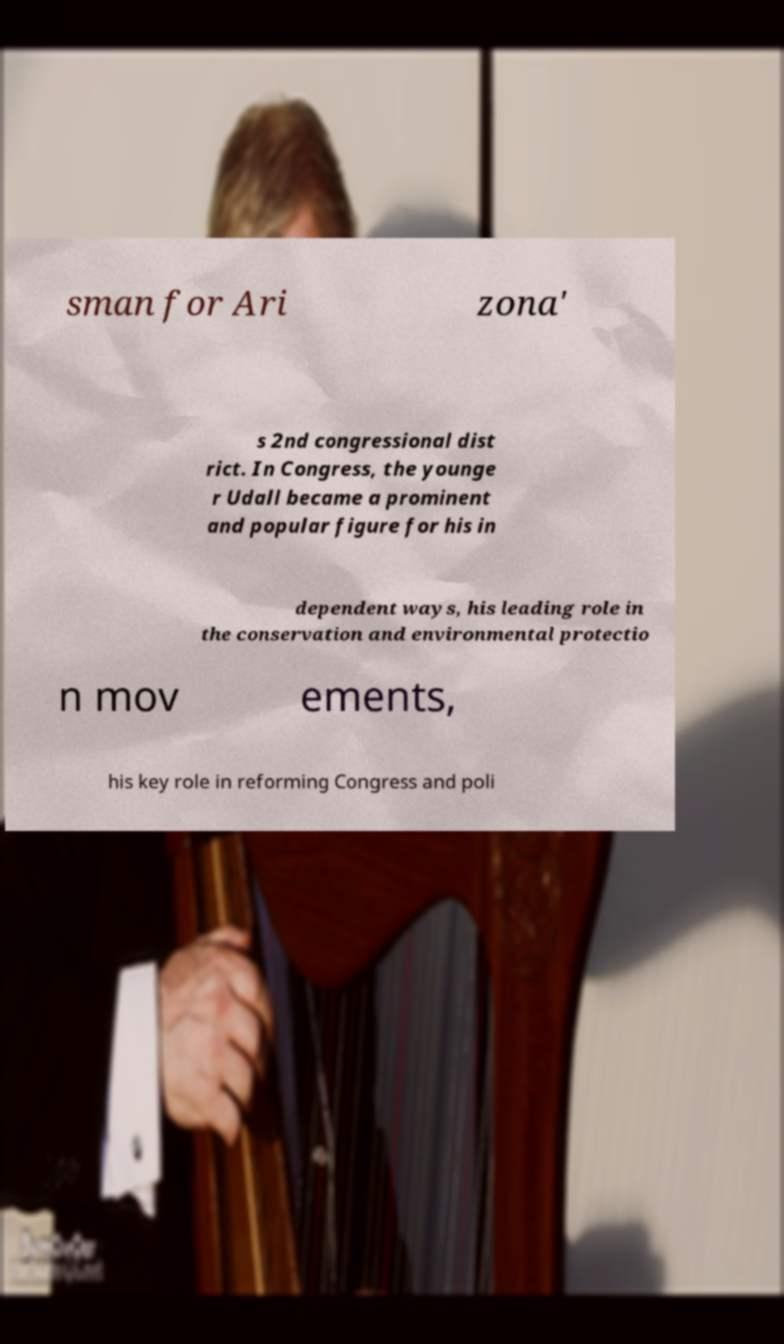For documentation purposes, I need the text within this image transcribed. Could you provide that? sman for Ari zona' s 2nd congressional dist rict. In Congress, the younge r Udall became a prominent and popular figure for his in dependent ways, his leading role in the conservation and environmental protectio n mov ements, his key role in reforming Congress and poli 